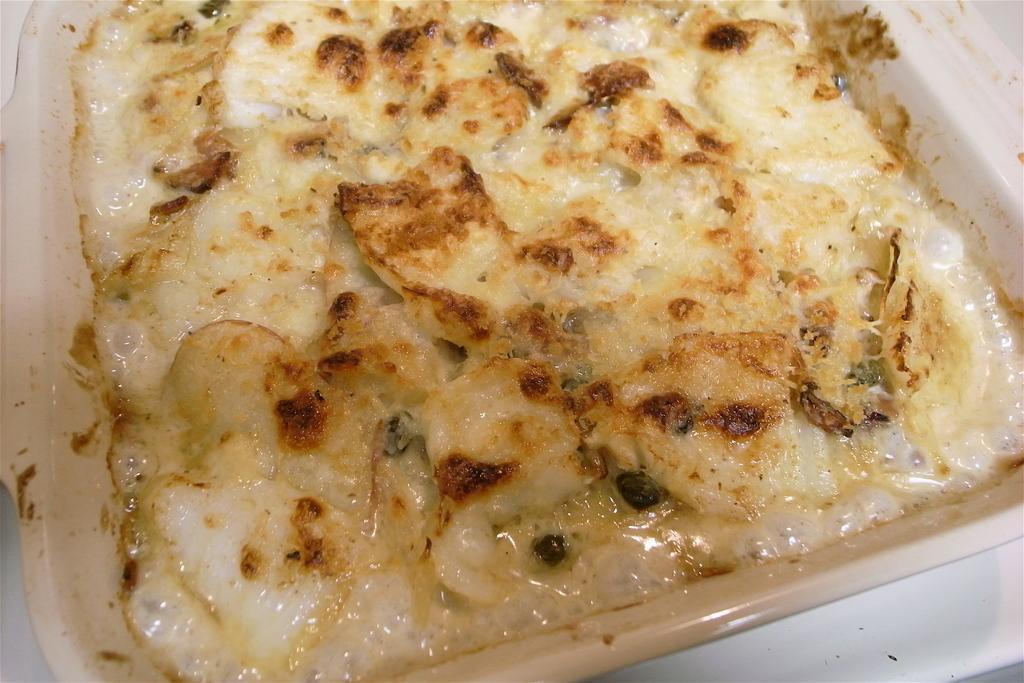Could you give a brief overview of what you see in this image? In the center of the image, we can see food in the tray. 